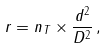<formula> <loc_0><loc_0><loc_500><loc_500>r = n _ { T } \times \frac { d ^ { 2 } } { D ^ { 2 } } \, ,</formula> 